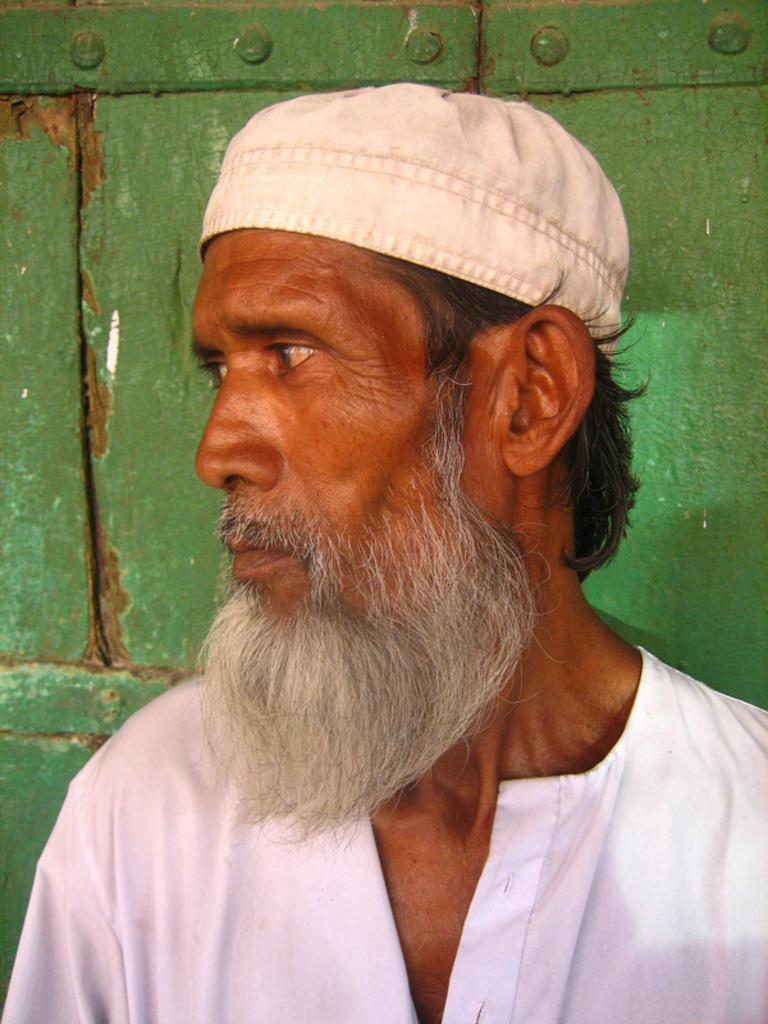Can you describe this image briefly? There is a man looking at left side and wore cap, behind him it is green. 